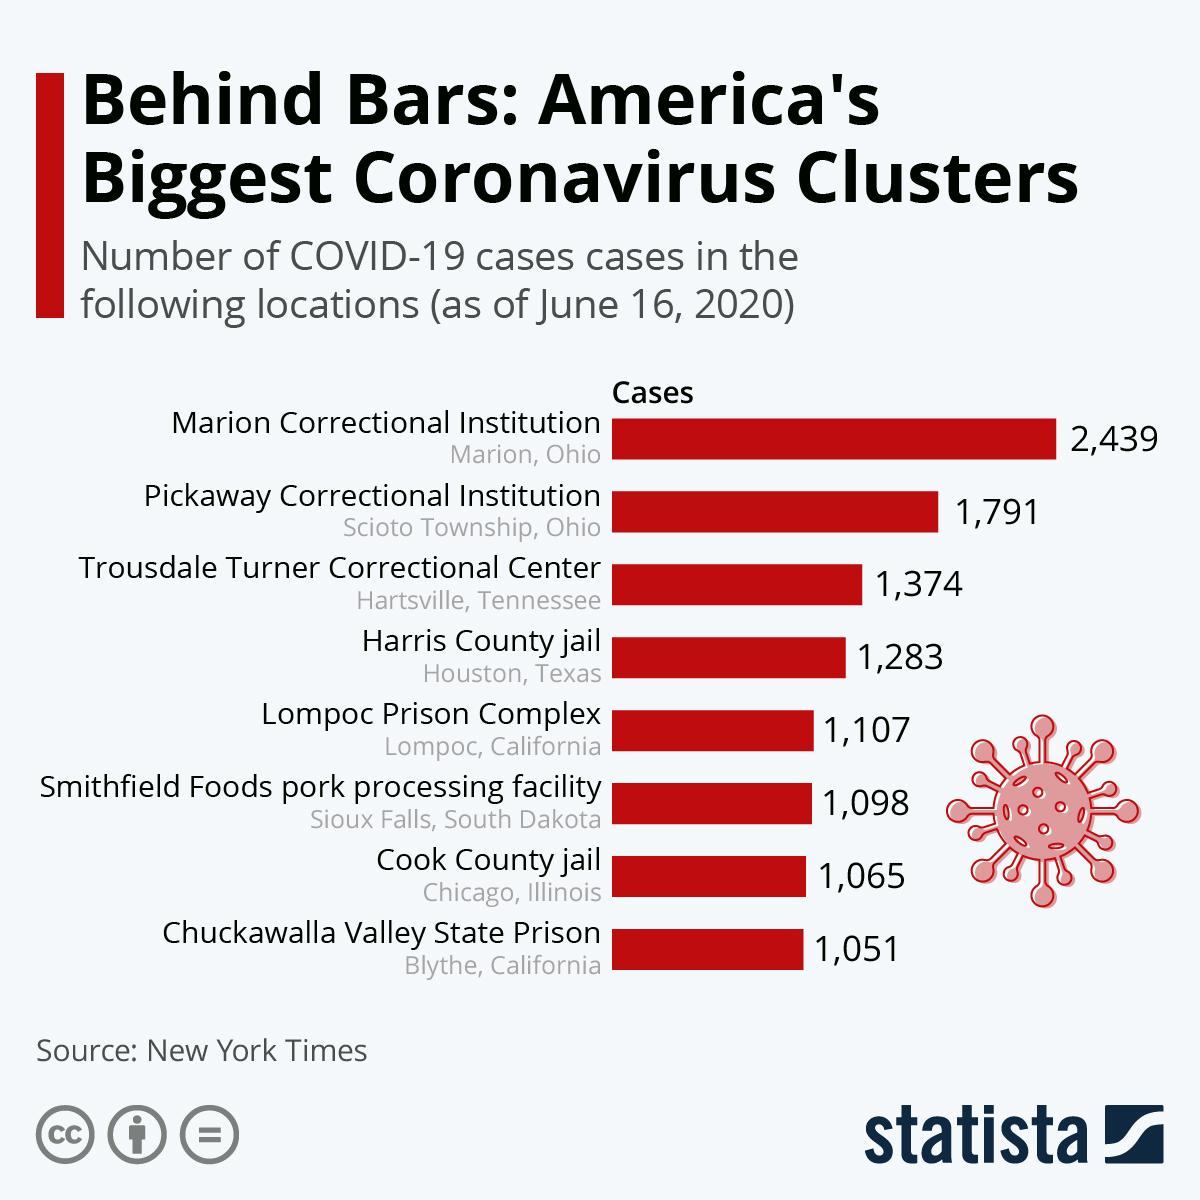Highlight a few significant elements in this photo. On June 16, 2020, Cook County Jail in Chicago had a total of 1,065 COVID-19 cases. As of June 16, 2020, there were 1,283 reported cases of Covid-19 in the Harris County jail in Houston, Texas. 